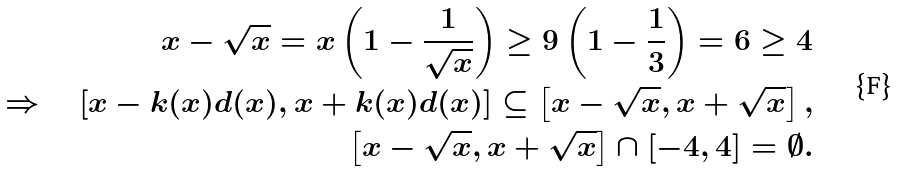<formula> <loc_0><loc_0><loc_500><loc_500>x - \sqrt { x } = x \left ( 1 - \frac { 1 } { \sqrt { x } } \right ) \geq 9 \left ( 1 - \frac { 1 } { 3 } \right ) = 6 \geq 4 \\ \Rightarrow \quad [ x - k ( x ) d ( x ) , x + k ( x ) d ( x ) ] \subseteq \left [ x - \sqrt { x } , x + \sqrt { x } \right ] , \\ \left [ x - \sqrt { x } , x + \sqrt { x } \right ] \cap [ - 4 , 4 ] = \emptyset .</formula> 